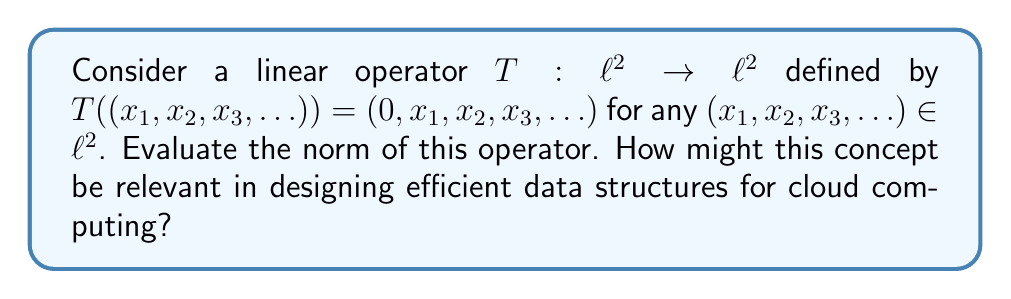Solve this math problem. To evaluate the norm of the bounded linear operator $T$, we need to find:

$$\|T\| = \sup_{\|x\| \leq 1} \|Tx\|$$

Let's approach this step-by-step:

1) First, observe that $T$ shifts all elements of the input sequence to the right and inserts a 0 at the beginning.

2) For any $x = (x_1, x_2, x_3, \ldots) \in \ell^2$, we have:
   
   $Tx = (0, x_1, x_2, x_3, \ldots)$

3) Now, let's calculate $\|Tx\|^2$:

   $$\|Tx\|^2 = 0^2 + x_1^2 + x_2^2 + x_3^2 + \ldots = \|x\|^2$$

4) This means that $\|Tx\| = \|x\|$ for all $x \in \ell^2$.

5) Therefore, for any $x$ with $\|x\| \leq 1$, we have $\|Tx\| \leq 1$.

6) Moreover, this upper bound is achieved when $\|x\| = 1$.

Thus, we can conclude that $\|T\| = 1$.

Relevance to cloud computing:
Understanding operator norms is crucial in analyzing the efficiency and stability of algorithms in cloud computing. For instance, in data processing or machine learning algorithms running on cloud infrastructure, operator norms can help in:

1) Estimating computational complexity and resource requirements.
2) Analyzing the stability and convergence of iterative methods.
3) Optimizing data movement and transformation operations in distributed systems.
4) Designing efficient compression algorithms for data transfer between cloud nodes.

The shift operator in this problem is analogous to operations often performed in data pipelines or stream processing in cloud architectures.
Answer: The norm of the operator $T$ is $\|T\| = 1$. 